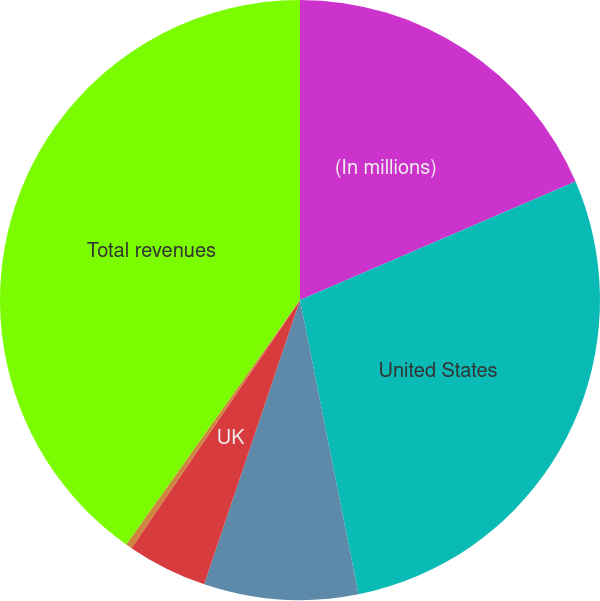Convert chart. <chart><loc_0><loc_0><loc_500><loc_500><pie_chart><fcel>(In millions)<fcel>United States<fcel>Equatorial Guinea<fcel>UK<fcel>Other international<fcel>Total revenues<nl><fcel>18.53%<fcel>28.34%<fcel>8.3%<fcel>4.32%<fcel>0.34%<fcel>40.16%<nl></chart> 